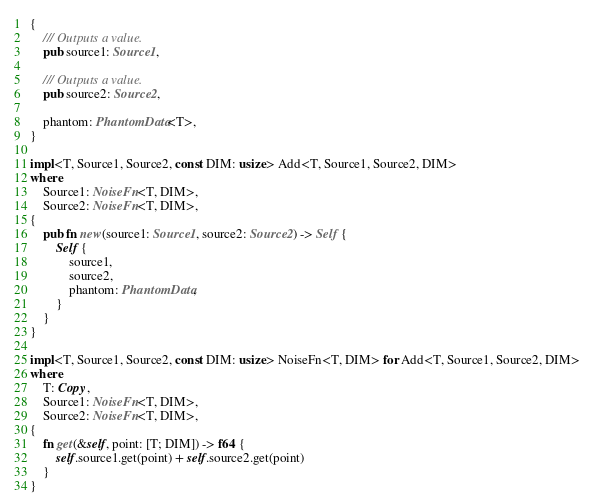<code> <loc_0><loc_0><loc_500><loc_500><_Rust_>{
    /// Outputs a value.
    pub source1: Source1,

    /// Outputs a value.
    pub source2: Source2,

    phantom: PhantomData<T>,
}

impl<T, Source1, Source2, const DIM: usize> Add<T, Source1, Source2, DIM>
where
    Source1: NoiseFn<T, DIM>,
    Source2: NoiseFn<T, DIM>,
{
    pub fn new(source1: Source1, source2: Source2) -> Self {
        Self {
            source1,
            source2,
            phantom: PhantomData,
        }
    }
}

impl<T, Source1, Source2, const DIM: usize> NoiseFn<T, DIM> for Add<T, Source1, Source2, DIM>
where
    T: Copy,
    Source1: NoiseFn<T, DIM>,
    Source2: NoiseFn<T, DIM>,
{
    fn get(&self, point: [T; DIM]) -> f64 {
        self.source1.get(point) + self.source2.get(point)
    }
}
</code> 